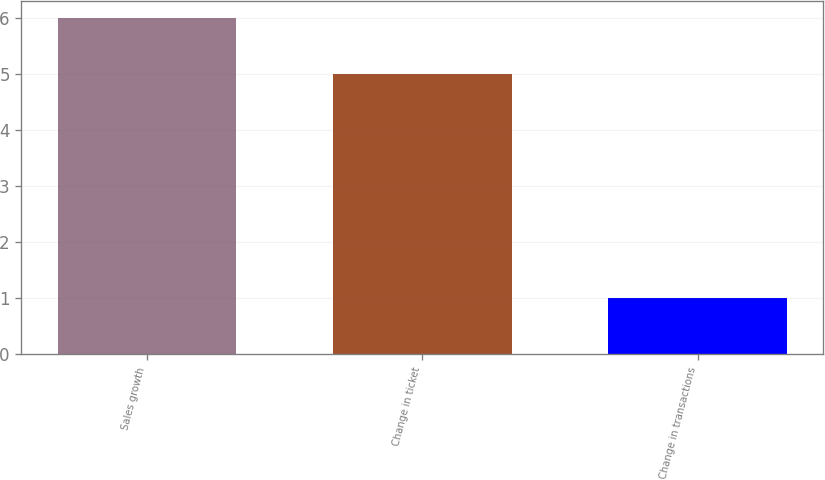<chart> <loc_0><loc_0><loc_500><loc_500><bar_chart><fcel>Sales growth<fcel>Change in ticket<fcel>Change in transactions<nl><fcel>6<fcel>5<fcel>1<nl></chart> 